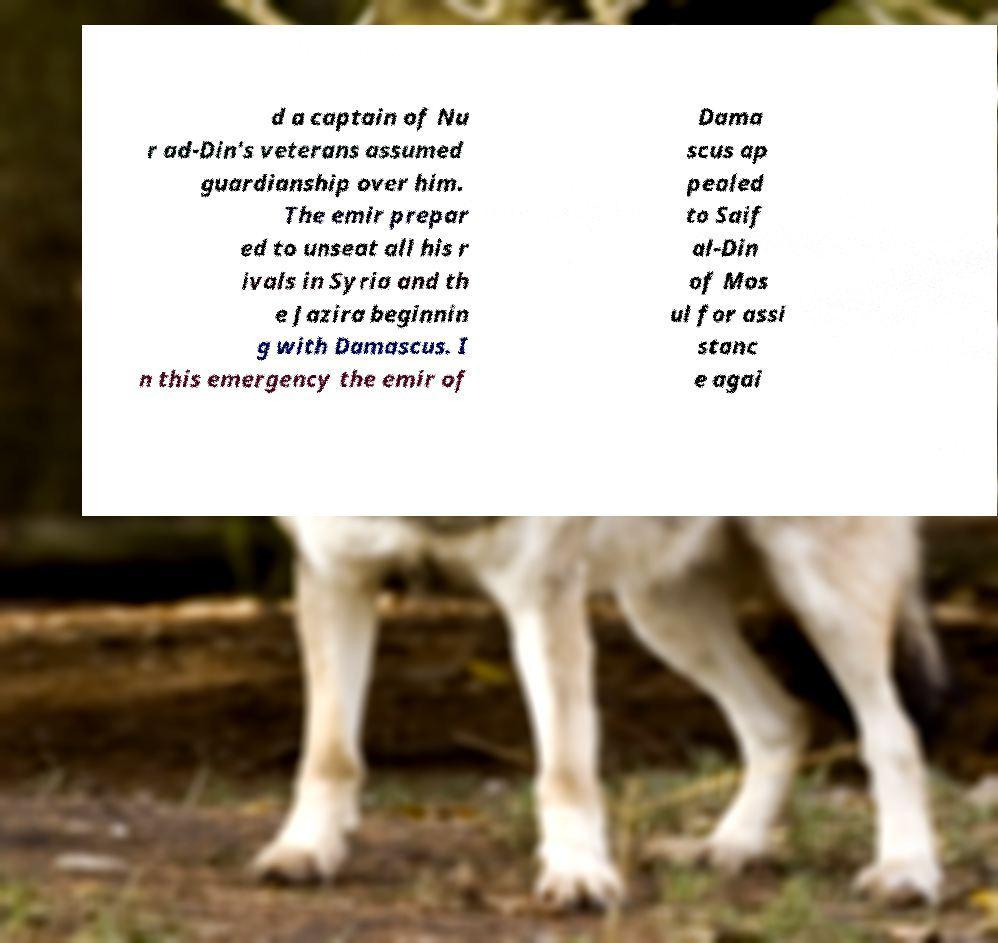Please read and relay the text visible in this image. What does it say? d a captain of Nu r ad-Din's veterans assumed guardianship over him. The emir prepar ed to unseat all his r ivals in Syria and th e Jazira beginnin g with Damascus. I n this emergency the emir of Dama scus ap pealed to Saif al-Din of Mos ul for assi stanc e agai 